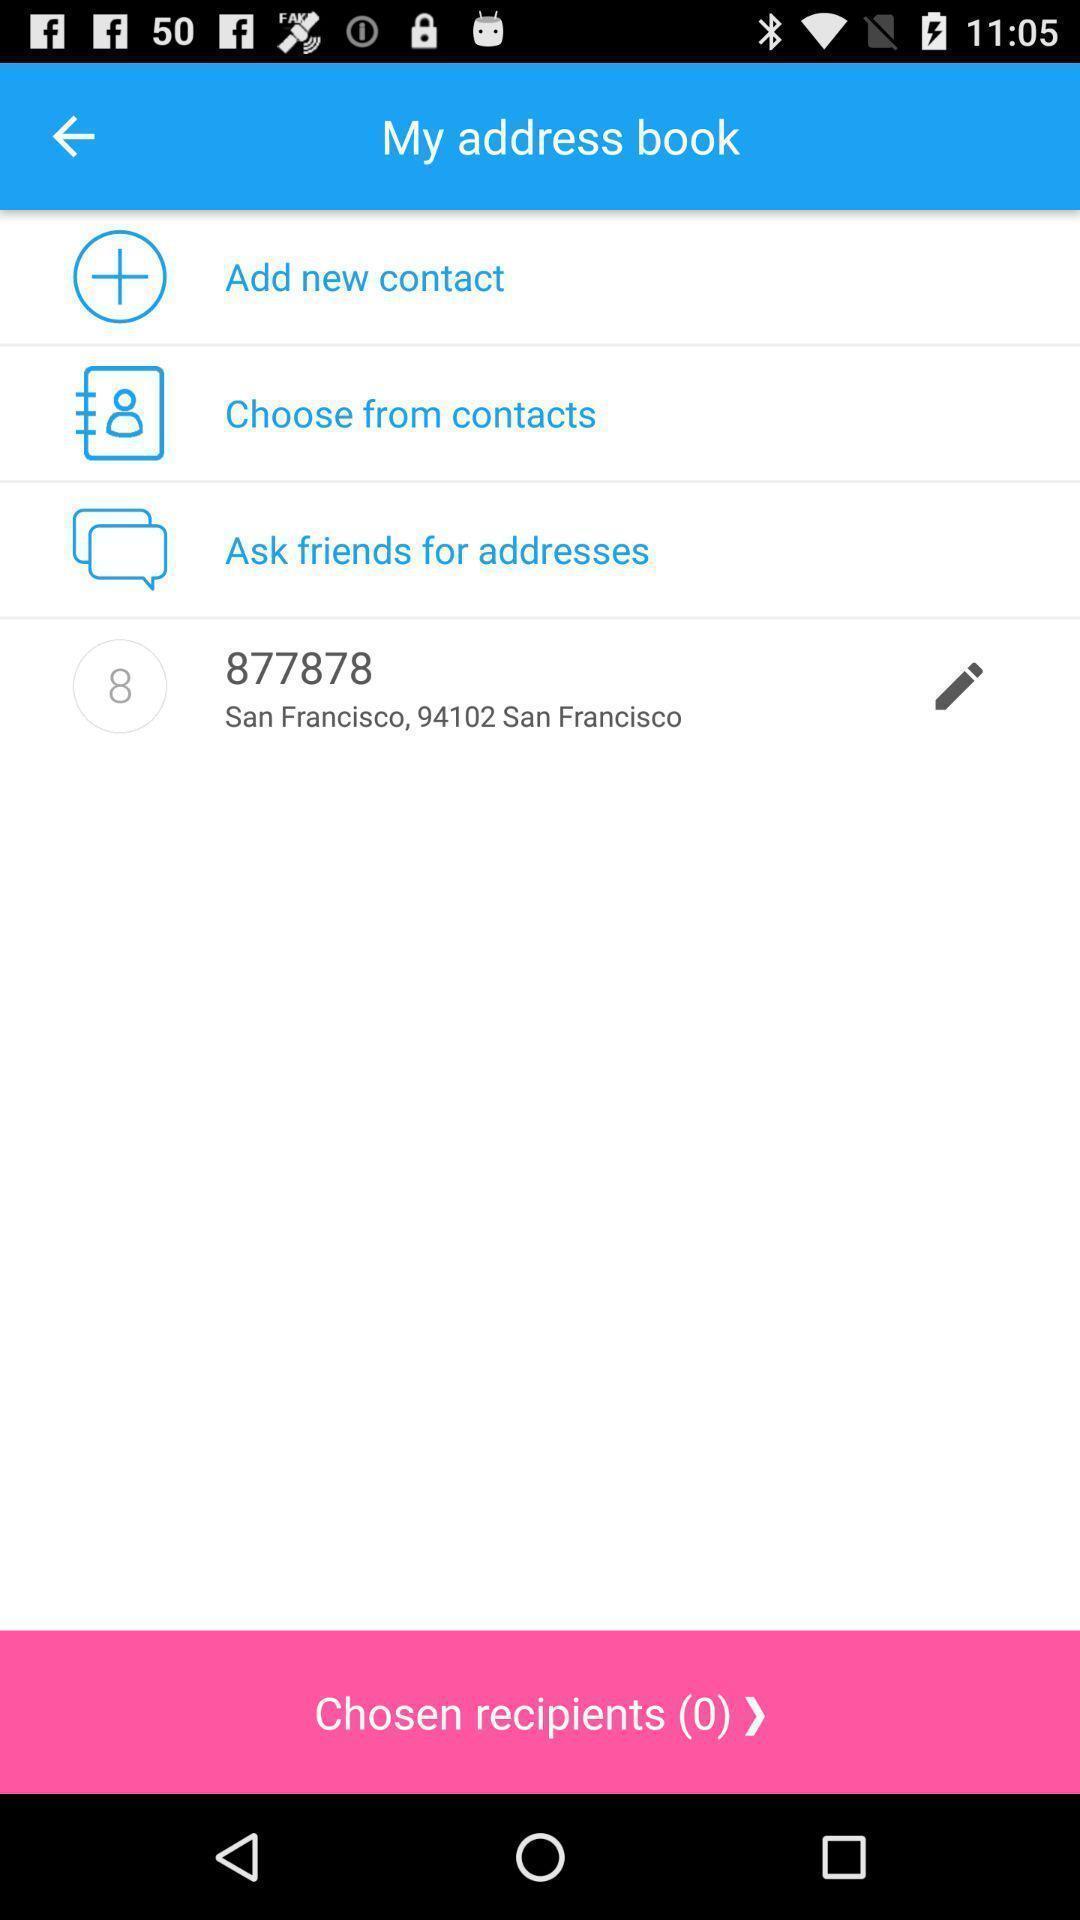Describe the content in this image. Page showing options in my address book. 